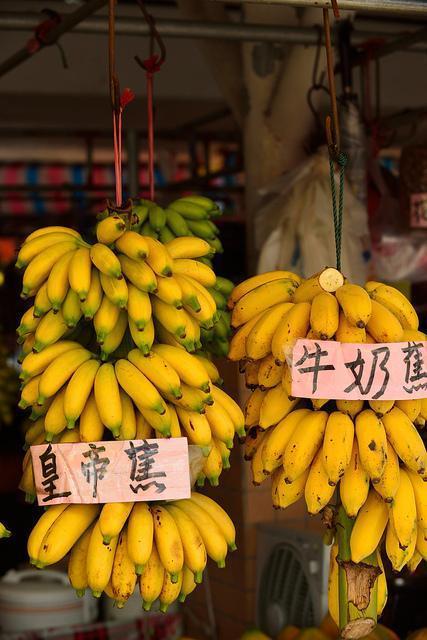How many bananas can be seen?
Give a very brief answer. 3. 